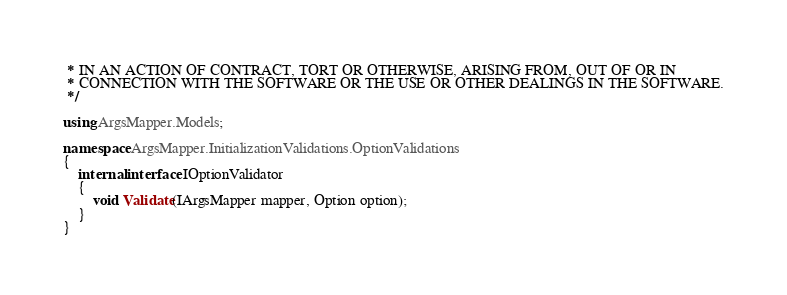Convert code to text. <code><loc_0><loc_0><loc_500><loc_500><_C#_> * IN AN ACTION OF CONTRACT, TORT OR OTHERWISE, ARISING FROM, OUT OF OR IN
 * CONNECTION WITH THE SOFTWARE OR THE USE OR OTHER DEALINGS IN THE SOFTWARE.
 */

using ArgsMapper.Models;

namespace ArgsMapper.InitializationValidations.OptionValidations
{
    internal interface IOptionValidator
    {
        void Validate(IArgsMapper mapper, Option option);
    }
}
</code> 